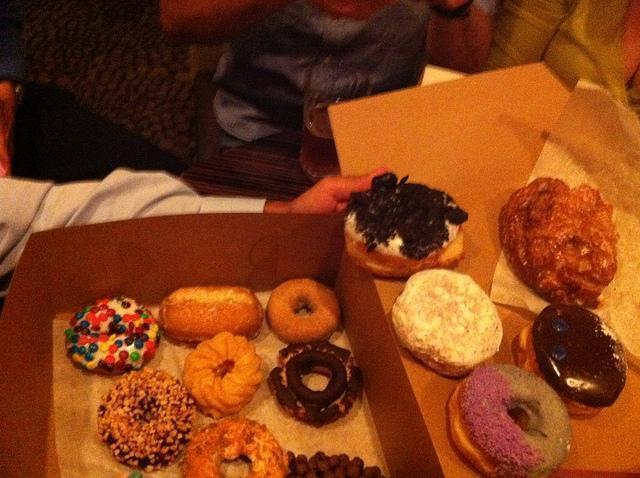What unhealthy ingredient does this food contain the most?
From the following four choices, select the correct answer to address the question.
Options: Flour, sugar, nuts, chocolate. Sugar. 